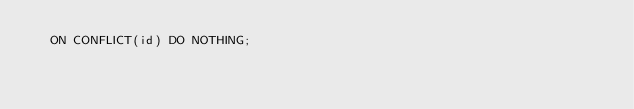<code> <loc_0><loc_0><loc_500><loc_500><_SQL_>  ON CONFLICT(id) DO NOTHING;
</code> 